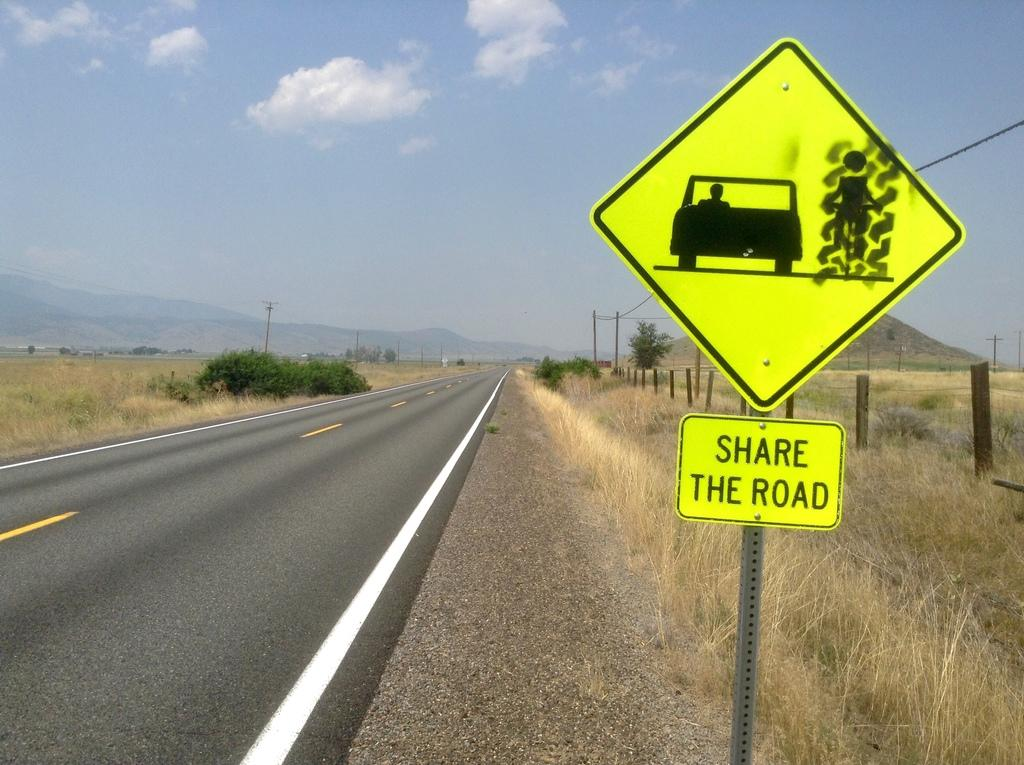<image>
Give a short and clear explanation of the subsequent image. A yellow sign tells people to share the road while they are driving. 